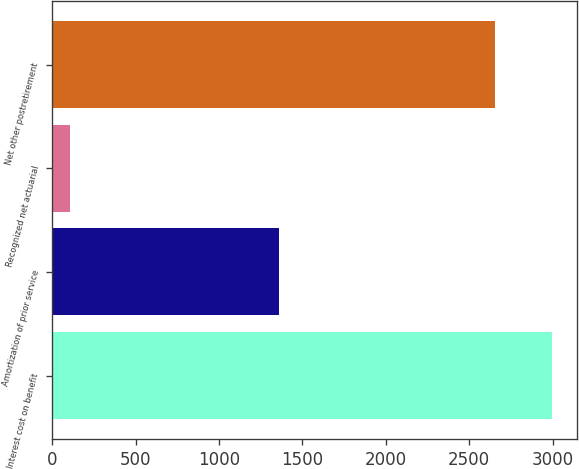Convert chart. <chart><loc_0><loc_0><loc_500><loc_500><bar_chart><fcel>Interest cost on benefit<fcel>Amortization of prior service<fcel>Recognized net actuarial<fcel>Net other postretirement<nl><fcel>2995<fcel>1359<fcel>106<fcel>2656<nl></chart> 